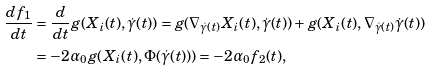<formula> <loc_0><loc_0><loc_500><loc_500>\frac { d f _ { 1 } } { d t } & = \frac { d } { d t } g ( X _ { i } ( t ) , \dot { \gamma } ( t ) ) = g ( \nabla _ { \dot { \gamma } ( t ) } X _ { i } ( t ) , \dot { \gamma } ( t ) ) + g ( X _ { i } ( t ) , \nabla _ { \dot { \gamma } ( t ) } \dot { \gamma } ( t ) ) \\ & = - 2 \alpha _ { 0 } g ( X _ { i } ( t ) , \Phi ( \dot { \gamma } ( t ) ) ) = - 2 \alpha _ { 0 } f _ { 2 } ( t ) ,</formula> 